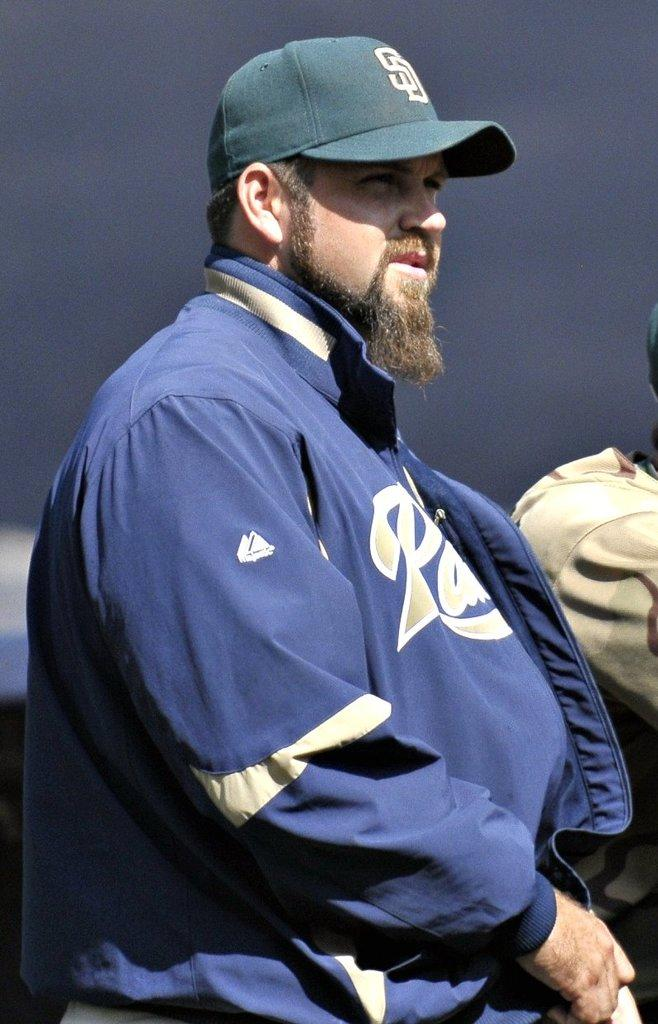What is the main subject of the image? There is a man standing in the image. What is the man wearing on his head? The man is wearing a cap. What type of clothing is the man wearing on his upper body? The man is wearing a jacket. Can you describe the person visible in the background of the image? Unfortunately, the provided facts do not give any information about the person in the background. What type of plantation can be seen in the background of the image? There is no plantation visible in the image. How many beds are present in the image? There is no mention of beds in the provided facts. 